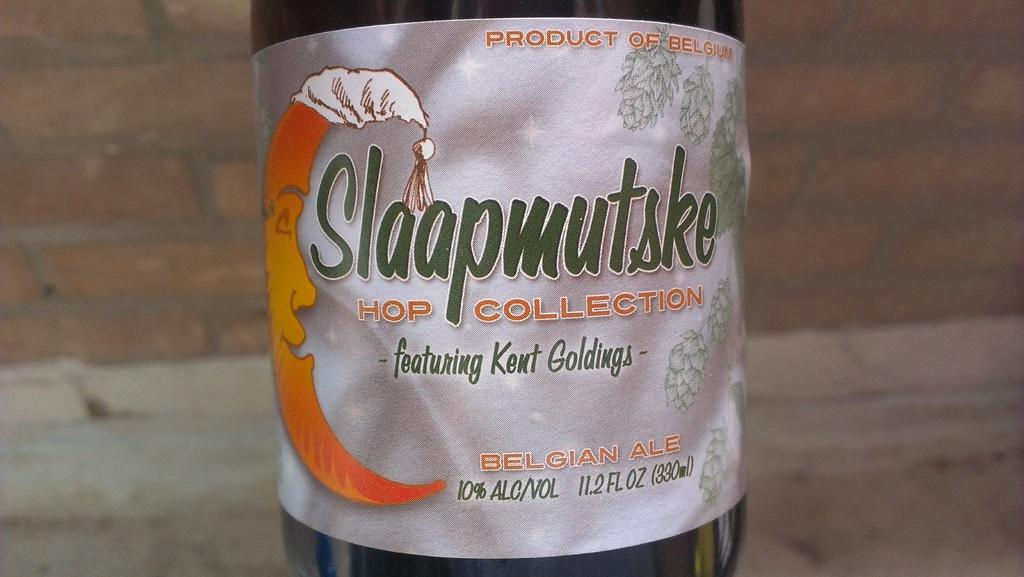What object can be seen in the image? There is a bottle in the image. What type of structure is visible in the background of the image? There is a brick wall in the background of the image. What type of coach is driving the beast in the image? There is no coach or beast present in the image; it only features a bottle and a brick wall. 